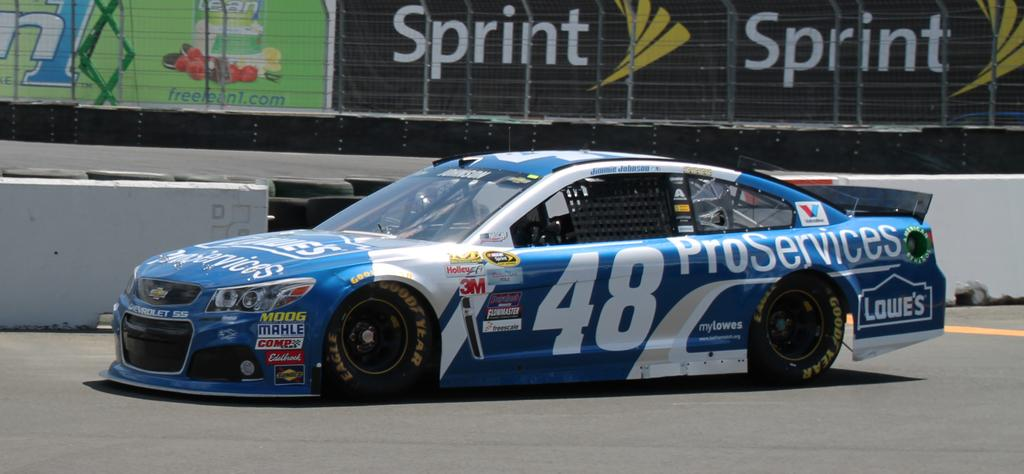What is the main subject of the image? The main subject of the image is a car. What can be seen on the car? The car has text and numbers on it. What is the setting of the image? There is a road, a barrier, and a fence in the image. What is visible behind the fence? There are text boards visible behind the fence. Can you tell me how many pots are placed under the umbrella in the image? There is no umbrella or pot present in the image; it features a car in a setting with a road, barrier, and fence. What type of memory is stored in the car's computer system in the image? There is no mention of a car's computer system or memory in the image; it only shows a car with text and numbers on it. 